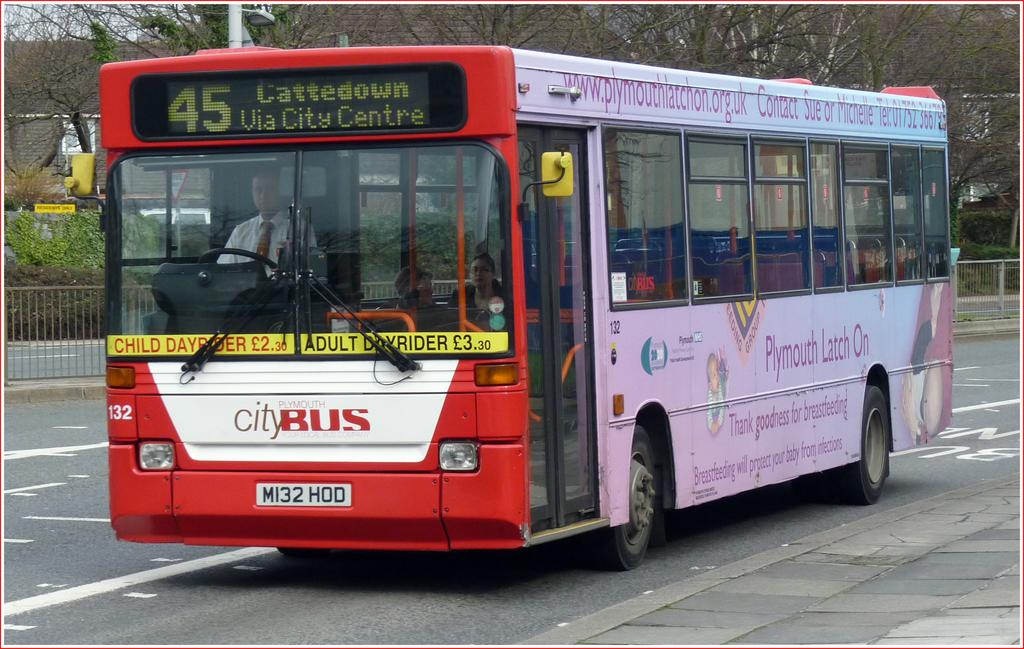<image>
Describe the image concisely. the name city bus that is on a bus 